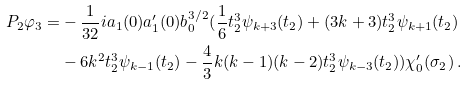<formula> <loc_0><loc_0><loc_500><loc_500>P _ { 2 } \varphi _ { 3 } = & - \frac { 1 } { 3 2 } i a _ { 1 } ( 0 ) a ^ { \prime } _ { 1 } ( 0 ) b ^ { 3 / 2 } _ { 0 } ( \frac { 1 } { 6 } t _ { 2 } ^ { 3 } \psi _ { k + 3 } ( t _ { 2 } ) + ( 3 k + 3 ) t _ { 2 } ^ { 3 } \psi _ { k + 1 } ( t _ { 2 } ) \\ & - 6 k ^ { 2 } t _ { 2 } ^ { 3 } \psi _ { k - 1 } ( t _ { 2 } ) - \frac { 4 } { 3 } k ( k - 1 ) ( k - 2 ) t _ { 2 } ^ { 3 } \psi _ { k - 3 } ( t _ { 2 } ) ) \chi ^ { \prime } _ { 0 } ( \sigma _ { 2 } ) \, .</formula> 